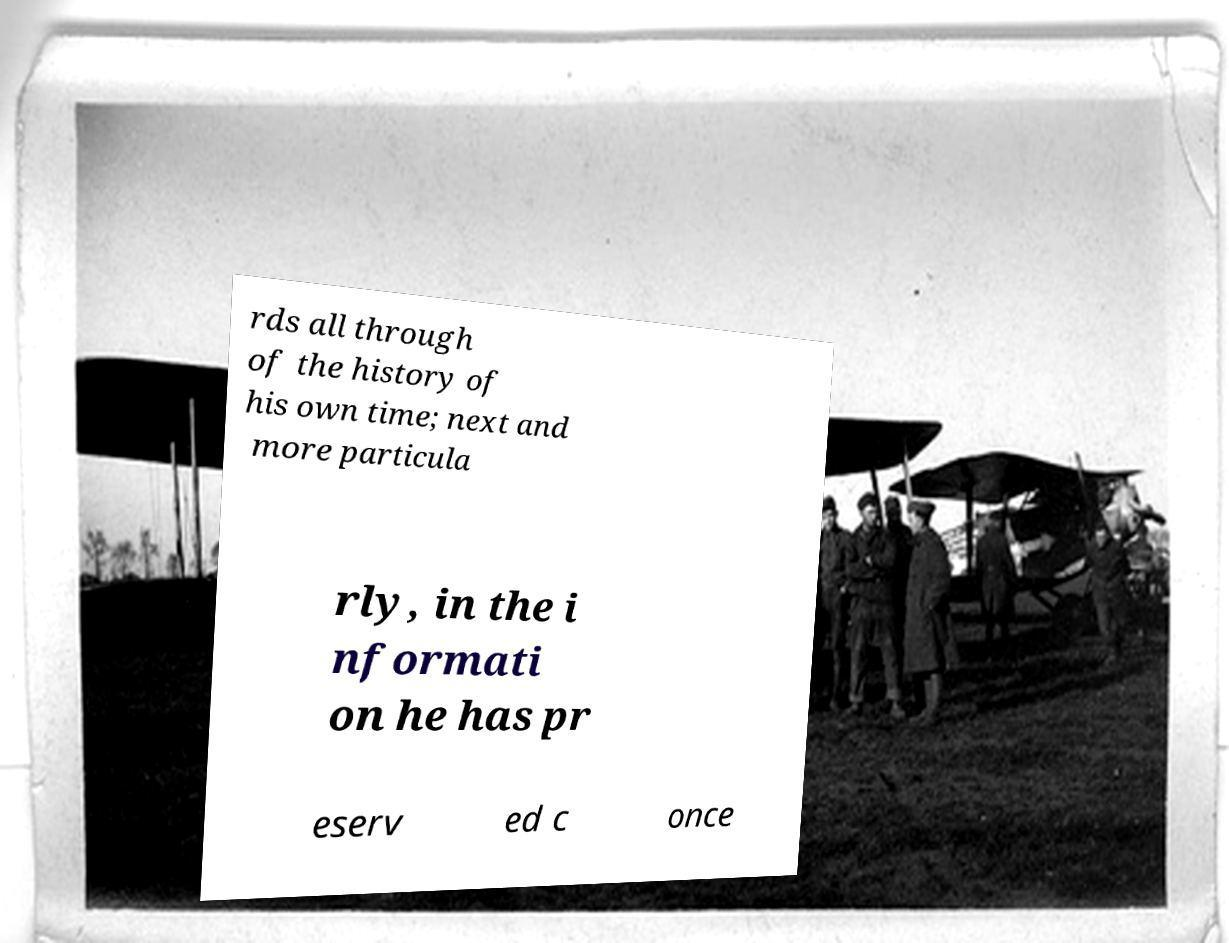Could you extract and type out the text from this image? rds all through of the history of his own time; next and more particula rly, in the i nformati on he has pr eserv ed c once 